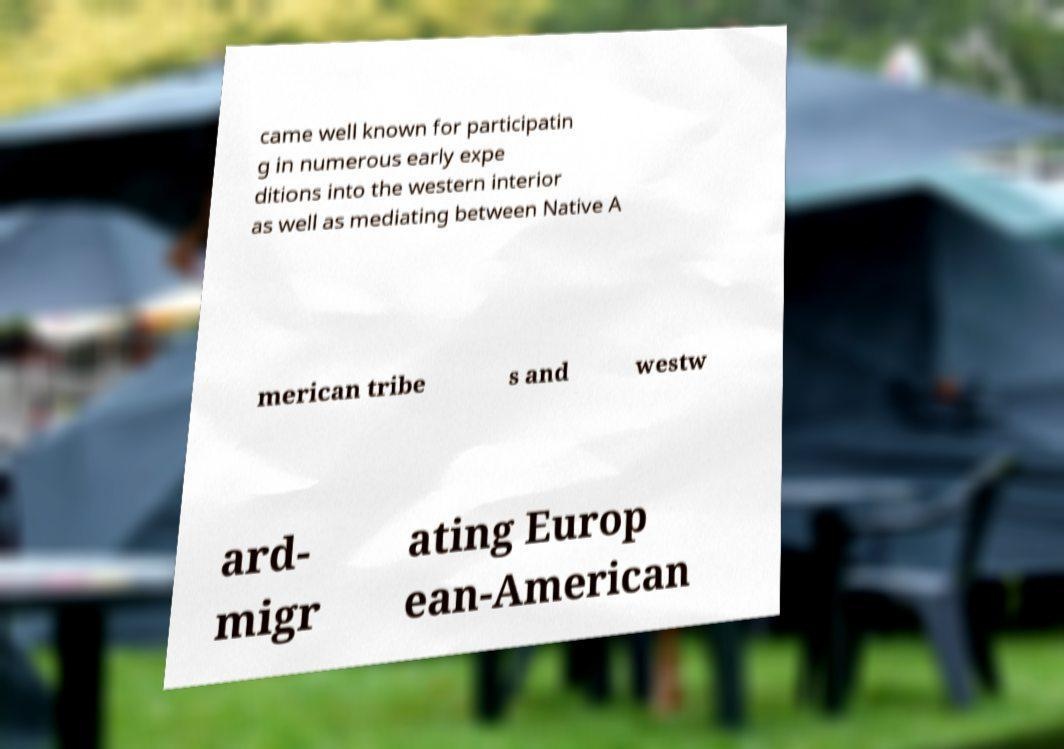There's text embedded in this image that I need extracted. Can you transcribe it verbatim? came well known for participatin g in numerous early expe ditions into the western interior as well as mediating between Native A merican tribe s and westw ard- migr ating Europ ean-American 